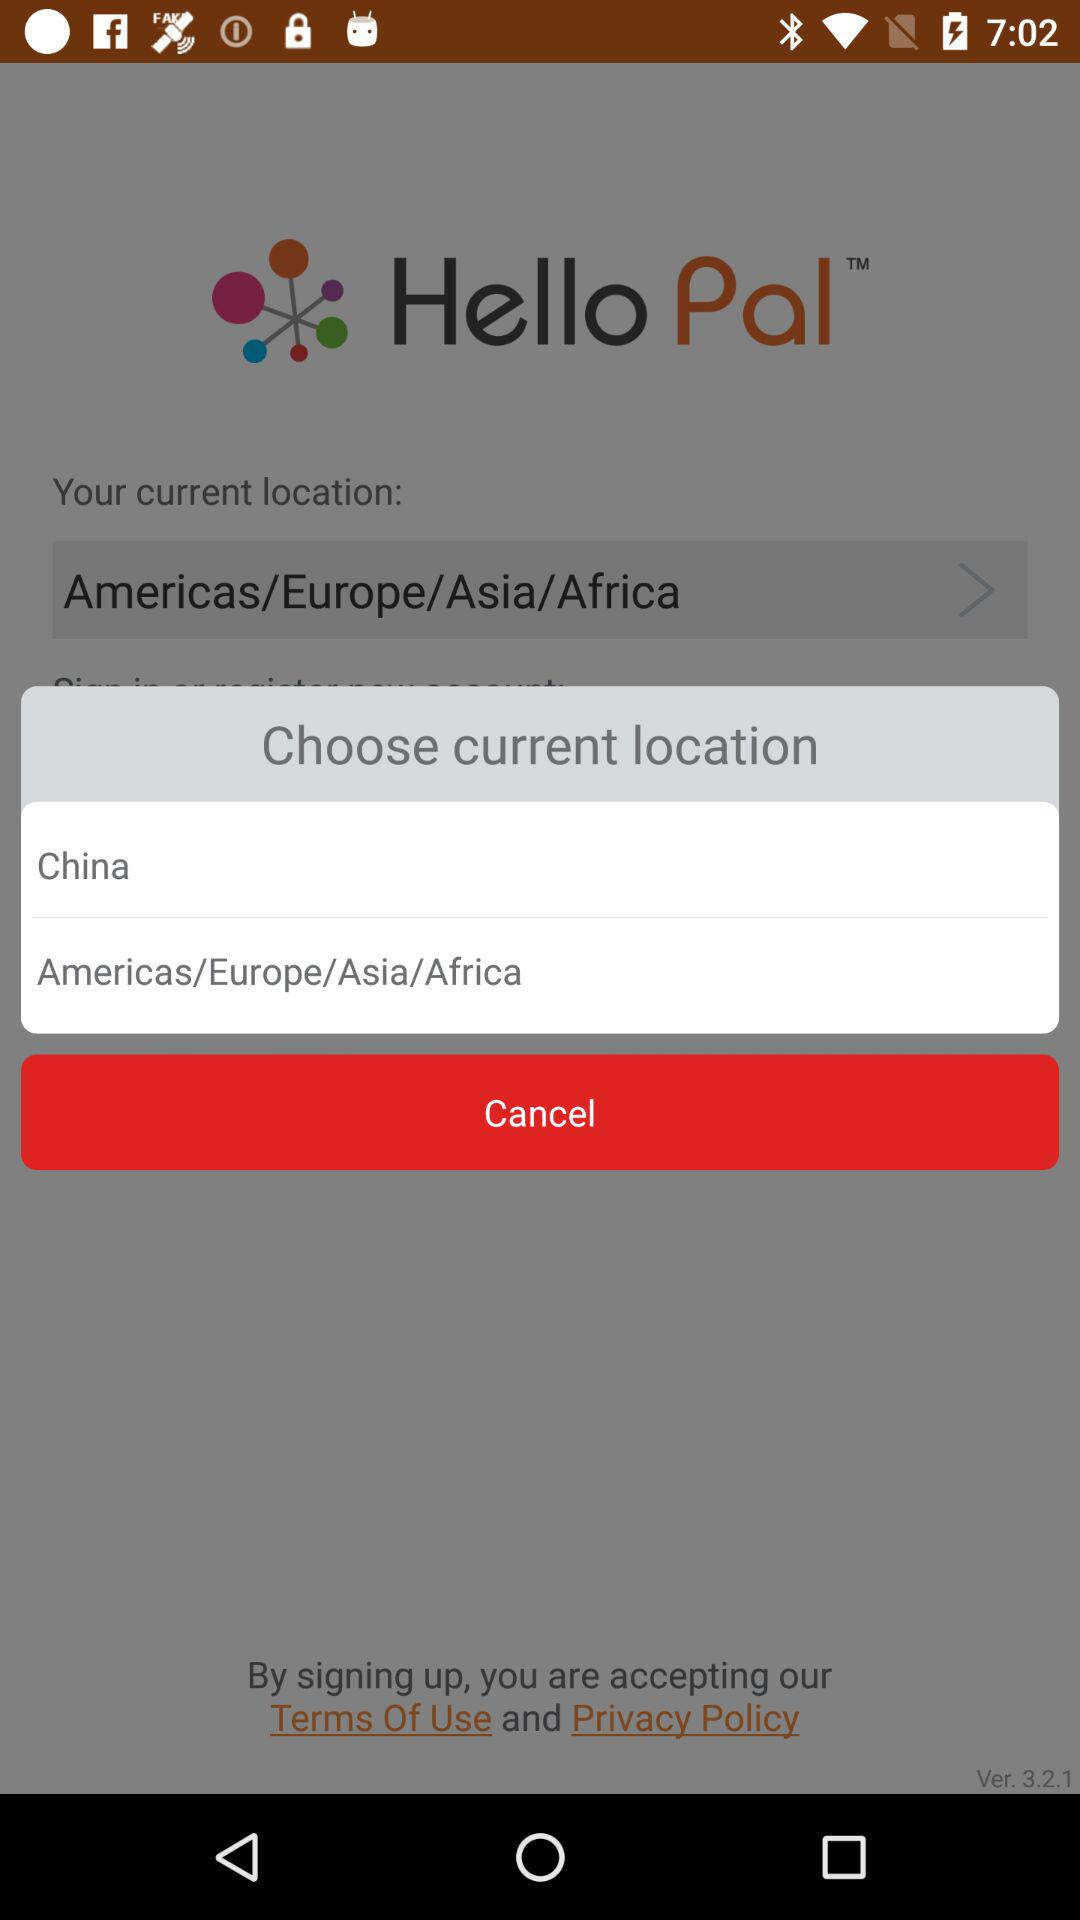Has the user agreed to the terms of use and privacy policy?
When the provided information is insufficient, respond with <no answer>. <no answer> 